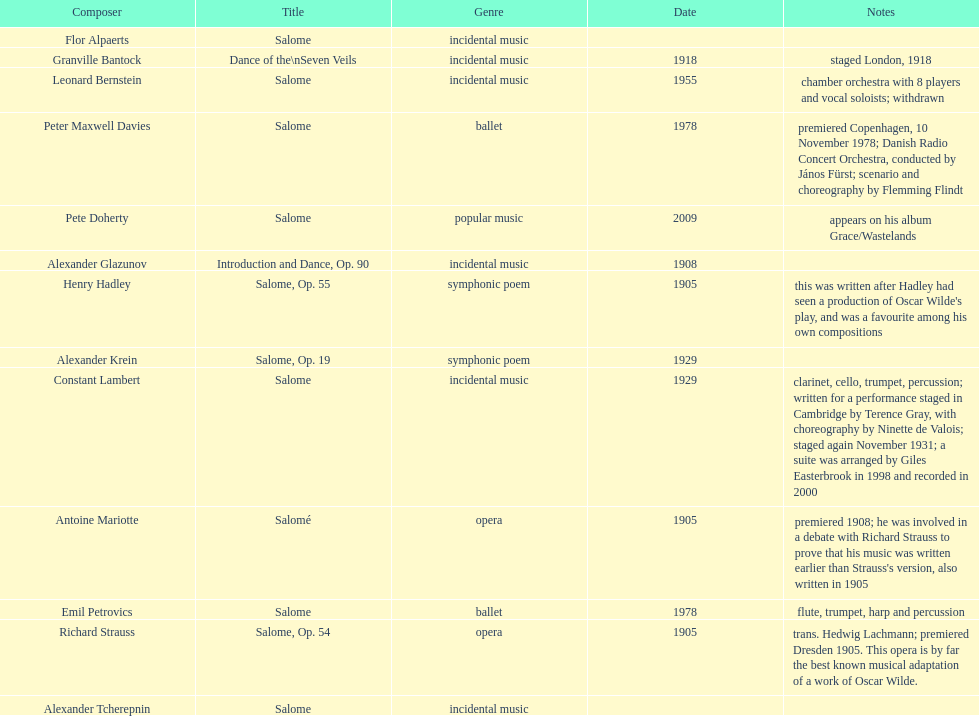What is the number of works titled "salome?" 11. 